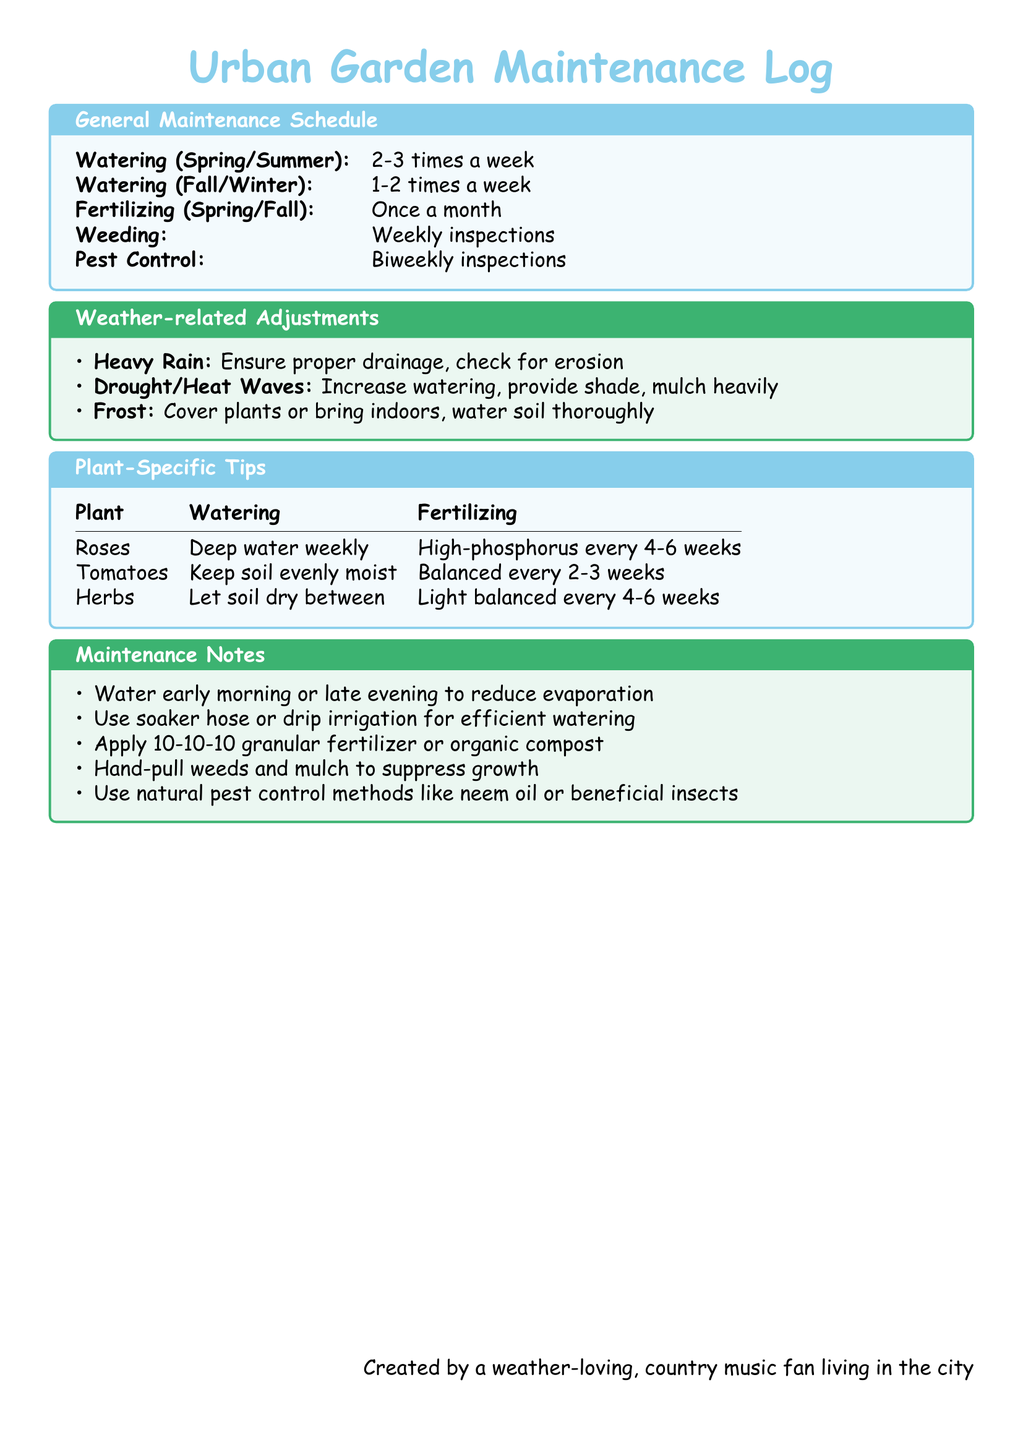What is the watering frequency in Spring/Summer? The document states that watering is done 2-3 times a week during Spring/Summer.
Answer: 2-3 times a week How often should pests be inspected? Pest control is scheduled for biweekly inspections according to the document.
Answer: Biweekly What type of fertilizer should be used for tomatoes? The plant-specific tips indicate that tomatoes should receive balanced fertilizer every 2-3 weeks.
Answer: Balanced What should be done during heavy rain? The document suggests ensuring proper drainage and checking for erosion during heavy rain.
Answer: Ensure proper drainage How often should roses be watered? According to the plant-specific tips, roses should be deep watered weekly.
Answer: Weekly What is the recommended action for frost conditions? The document advises covering plants or bringing them indoors when frost is expected.
Answer: Cover plants or bring indoors What should be done to suppress weed growth? The document recommends hand-pulling weeds and mulching to suppress growth.
Answer: Hand-pull weeds and mulch When is the best time to water to reduce evaporation? The document mentions watering early morning or late evening to reduce evaporation.
Answer: Early morning or late evening 